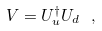Convert formula to latex. <formula><loc_0><loc_0><loc_500><loc_500>V = U _ { u } ^ { \dagger } U _ { d } \ ,</formula> 